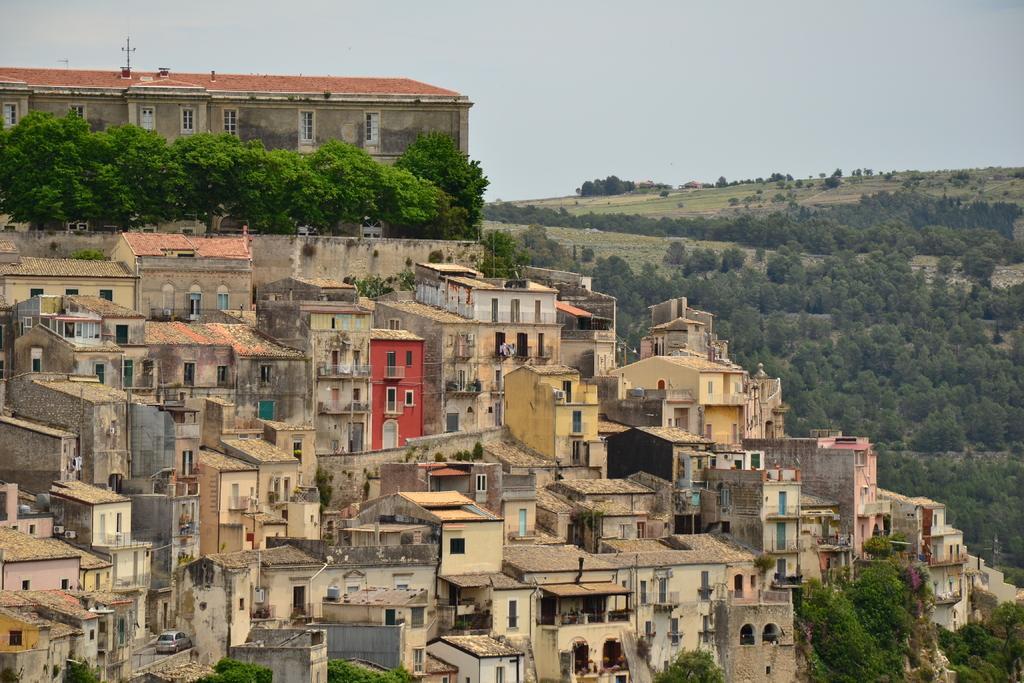How would you summarize this image in a sentence or two? This image is taken in outdoors. In this image there are many buildings with walls, windows and doors. In the right side of the image there are many trees and plants. In the top left of the image there are few trees. At the top of the image there is a sky. 